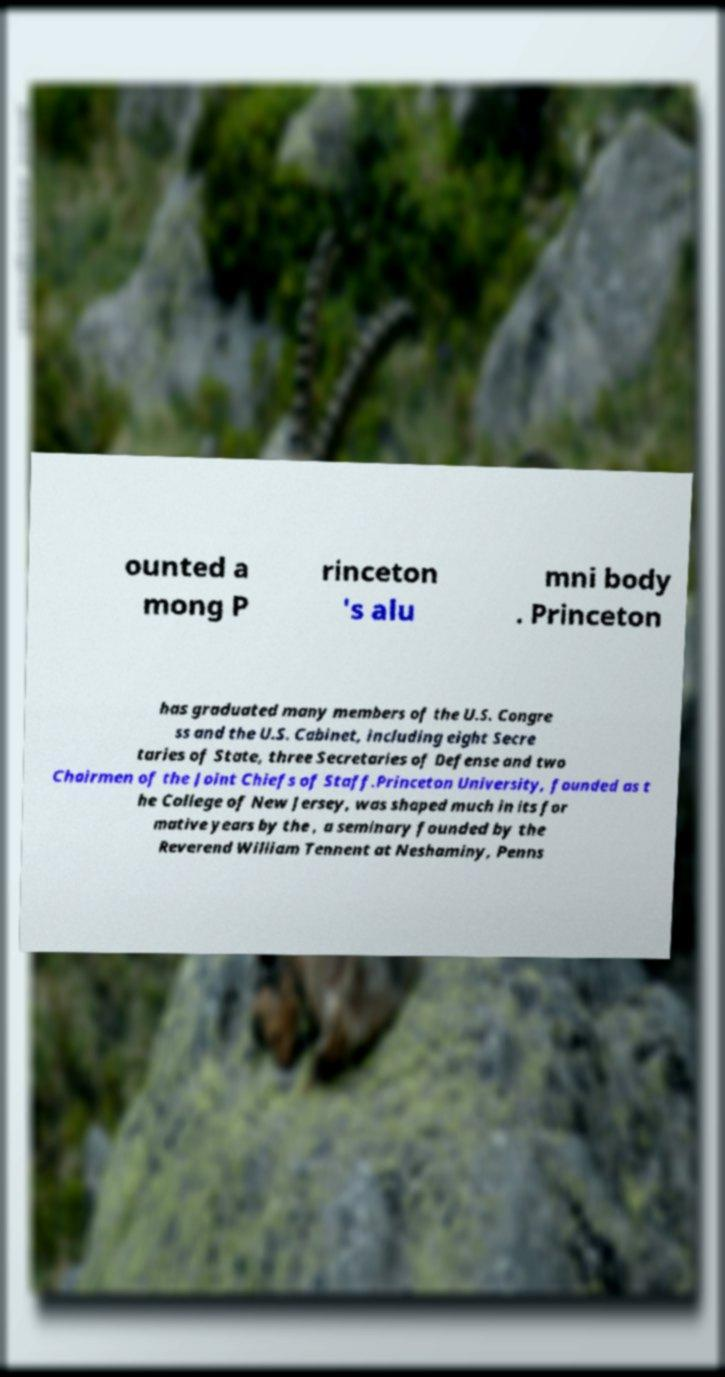Please identify and transcribe the text found in this image. ounted a mong P rinceton 's alu mni body . Princeton has graduated many members of the U.S. Congre ss and the U.S. Cabinet, including eight Secre taries of State, three Secretaries of Defense and two Chairmen of the Joint Chiefs of Staff.Princeton University, founded as t he College of New Jersey, was shaped much in its for mative years by the , a seminary founded by the Reverend William Tennent at Neshaminy, Penns 